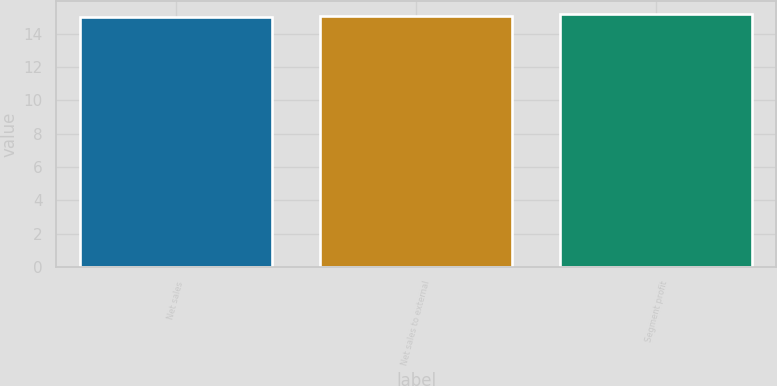Convert chart. <chart><loc_0><loc_0><loc_500><loc_500><bar_chart><fcel>Net sales<fcel>Net sales to external<fcel>Segment profit<nl><fcel>15<fcel>15.1<fcel>15.2<nl></chart> 